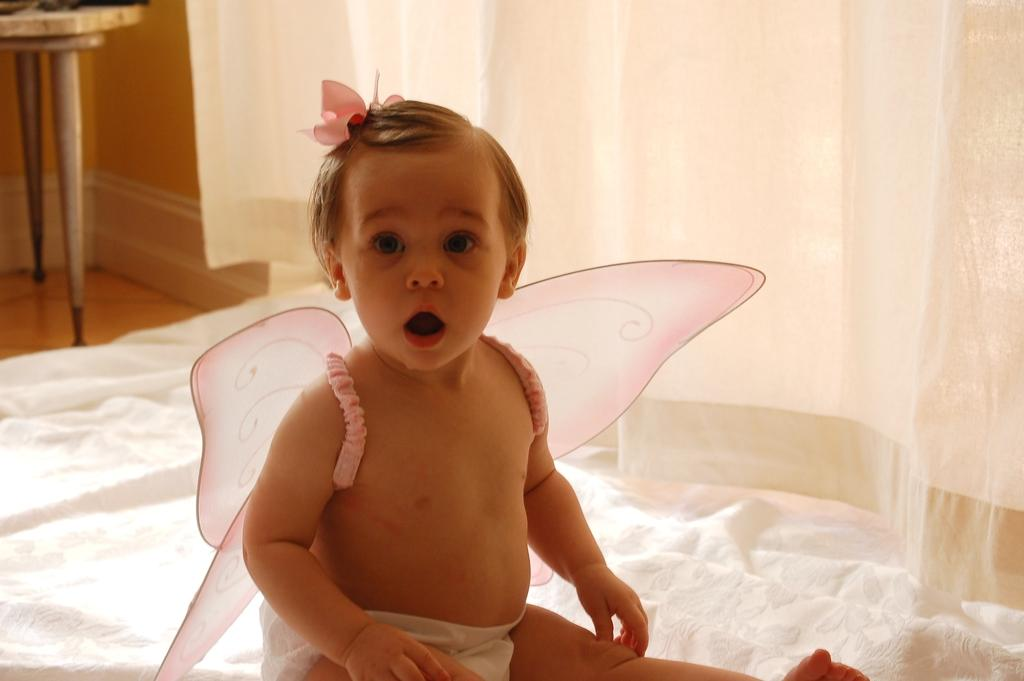What is the main subject of the image? There is a baby in the image. What is the baby wearing? The baby is wearing a costume. What position is the baby in? The baby is sitting. What type of material is visible in the image? There is cloth visible in the image. What type of window treatment is present in the image? There are curtains in the image. What is the background of the image made of? There is a wall on the left side of the image. What is the surface that the baby is sitting on? There is a floor in the image. What type of furniture is present in the image? There is a table in the image. What type of mint plant can be seen growing on the table in the image? There is no mint plant present on the table in the image. 